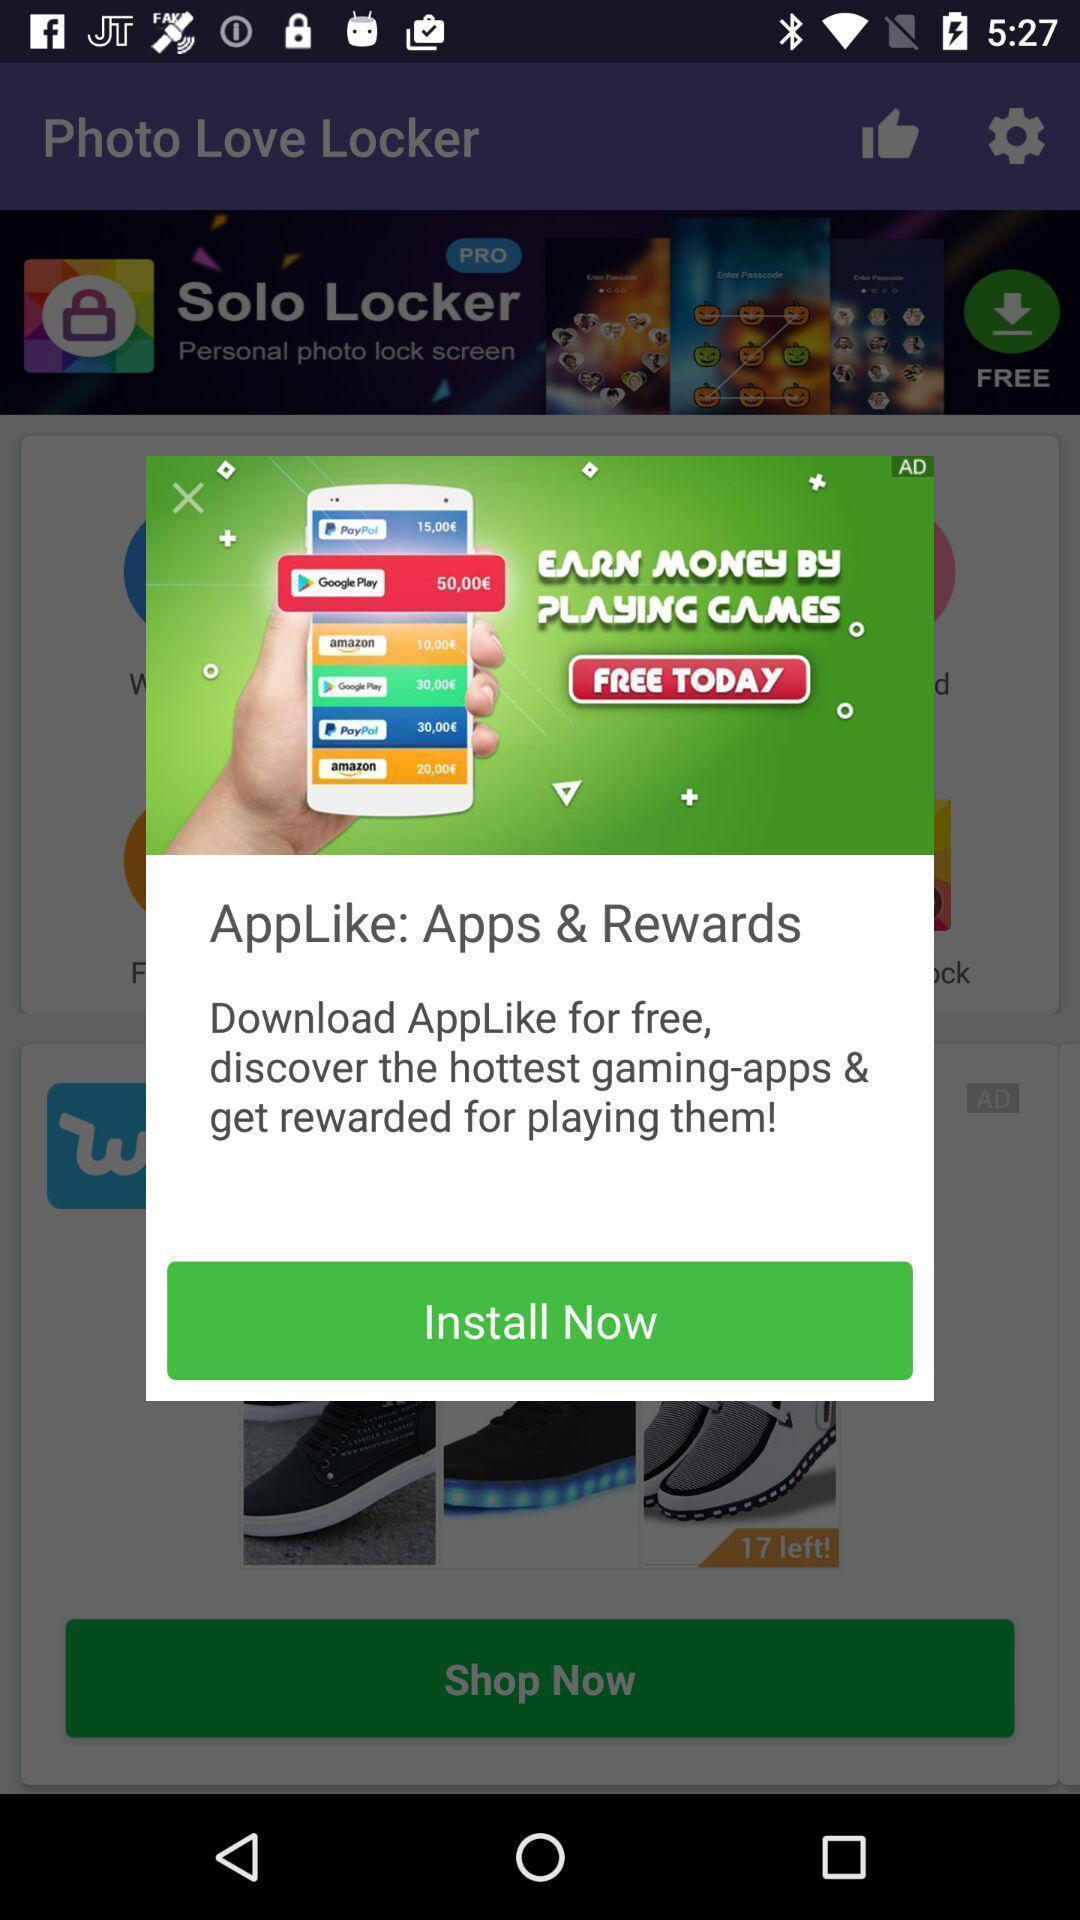Summarize the information in this screenshot. Pop-up window showing an advertisement of the app. 